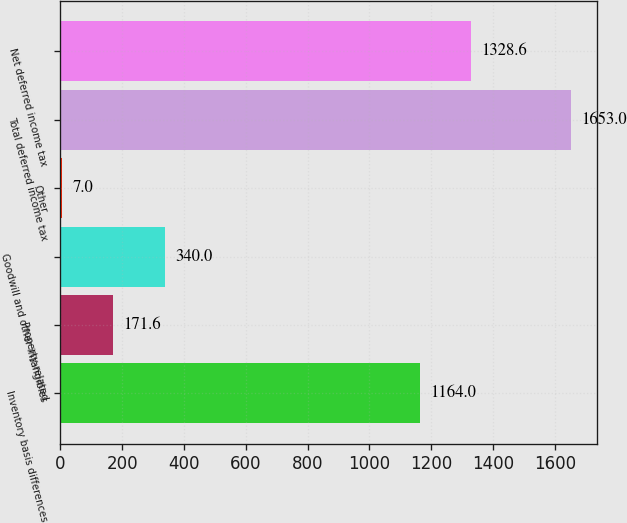<chart> <loc_0><loc_0><loc_500><loc_500><bar_chart><fcel>Inventory basis differences<fcel>Property-related<fcel>Goodwill and other intangibles<fcel>Other<fcel>Total deferred income tax<fcel>Net deferred income tax<nl><fcel>1164<fcel>171.6<fcel>340<fcel>7<fcel>1653<fcel>1328.6<nl></chart> 